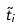Convert formula to latex. <formula><loc_0><loc_0><loc_500><loc_500>\tilde { t } _ { i }</formula> 